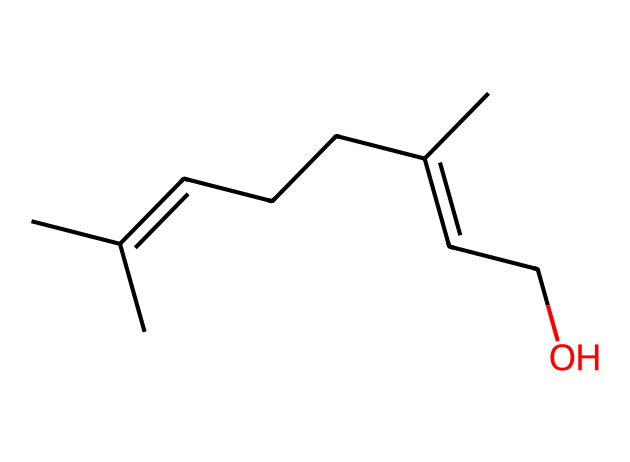What is the main functional group present in this chemical structure? The chemical contains an -OH group, which identifies it as an alcohol. The functional group responsible for its properties is the hydroxyl group (-OH).
Answer: alcohol How many carbon atoms are in this structure? By examining the SMILES representation, we can count the number of carbon atoms indicated. There are a total of 8 carbon atoms in the chain.
Answer: 8 Does this chemical likely have hydrophilic properties? The presence of the hydroxyl (alcohol) functional group suggests it can interact with water, giving it hydrophilic properties.
Answer: yes What type of chemical compound is this, given its structure? The structure illustrated is a type of long-chain alcohol that can act as a surfactant. Its structure resembles those used in natural insect repellents.
Answer: surfactant What is the effect of the alkene group in this chemical? The presence of the alkene group (double bond) adds to the reactivity of the molecule and can influence its interaction with other substances, contributing to its efficacy as an insect repellent.
Answer: reactivity What molecular feature gives this chemical its potential surfactant properties? The -OH group in combination with the long carbon chain allows for both hydrophilic (water-attracting) and hydrophobic (water-repelling) characteristics, which are essential in surfactant behavior.
Answer: amphiphilic 